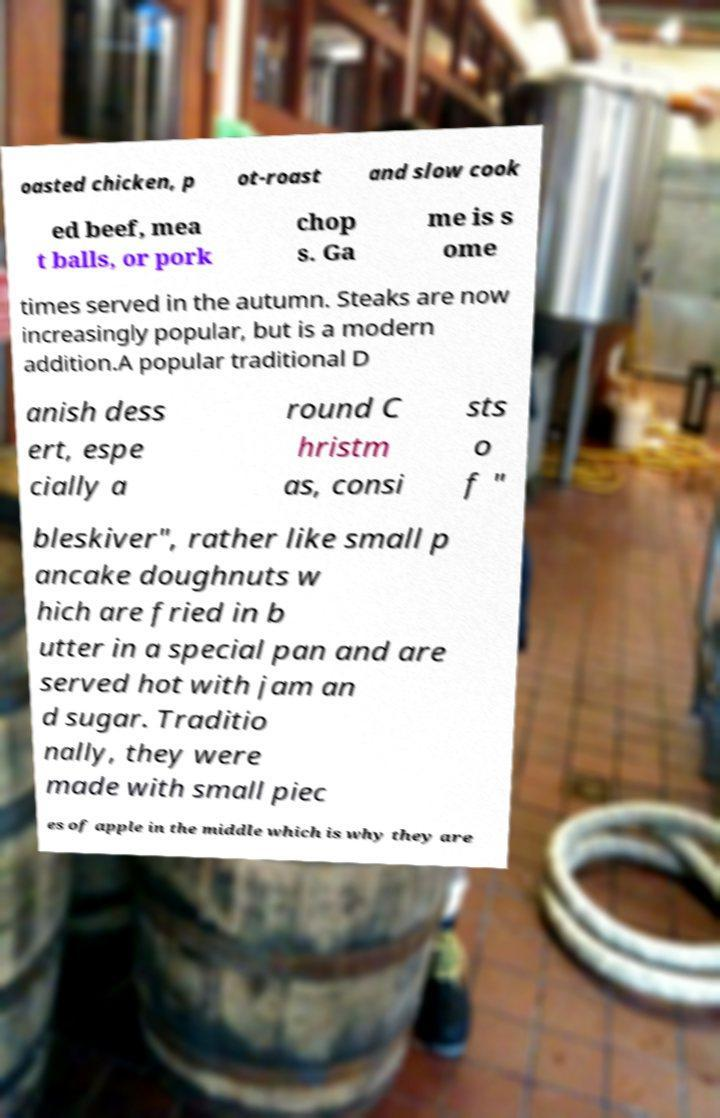Could you extract and type out the text from this image? oasted chicken, p ot-roast and slow cook ed beef, mea t balls, or pork chop s. Ga me is s ome times served in the autumn. Steaks are now increasingly popular, but is a modern addition.A popular traditional D anish dess ert, espe cially a round C hristm as, consi sts o f " bleskiver", rather like small p ancake doughnuts w hich are fried in b utter in a special pan and are served hot with jam an d sugar. Traditio nally, they were made with small piec es of apple in the middle which is why they are 